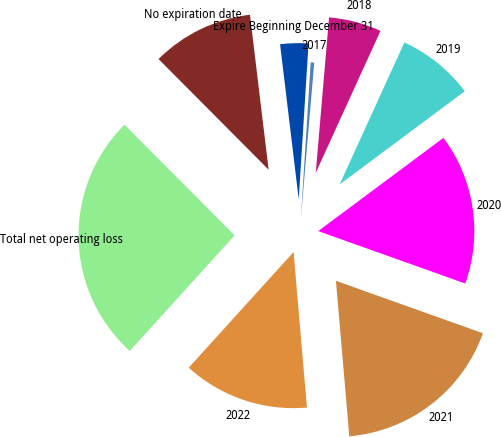Convert chart. <chart><loc_0><loc_0><loc_500><loc_500><pie_chart><fcel>Expire Beginning December 31<fcel>2017<fcel>2018<fcel>2019<fcel>2020<fcel>2021<fcel>2022<fcel>Total net operating loss<fcel>No expiration date<nl><fcel>2.91%<fcel>0.36%<fcel>5.45%<fcel>8.0%<fcel>15.64%<fcel>18.18%<fcel>13.09%<fcel>25.82%<fcel>10.55%<nl></chart> 